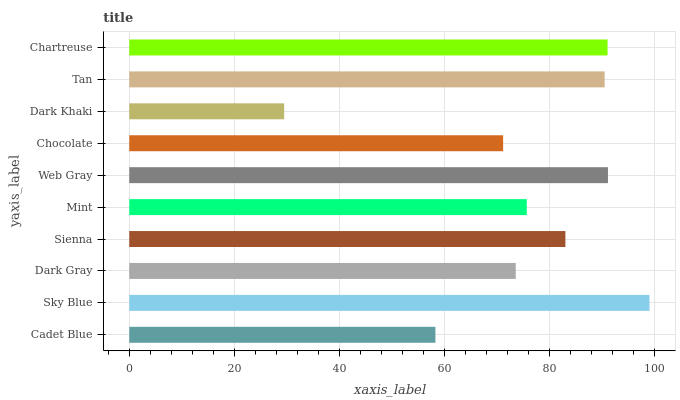Is Dark Khaki the minimum?
Answer yes or no. Yes. Is Sky Blue the maximum?
Answer yes or no. Yes. Is Dark Gray the minimum?
Answer yes or no. No. Is Dark Gray the maximum?
Answer yes or no. No. Is Sky Blue greater than Dark Gray?
Answer yes or no. Yes. Is Dark Gray less than Sky Blue?
Answer yes or no. Yes. Is Dark Gray greater than Sky Blue?
Answer yes or no. No. Is Sky Blue less than Dark Gray?
Answer yes or no. No. Is Sienna the high median?
Answer yes or no. Yes. Is Mint the low median?
Answer yes or no. Yes. Is Chocolate the high median?
Answer yes or no. No. Is Dark Gray the low median?
Answer yes or no. No. 